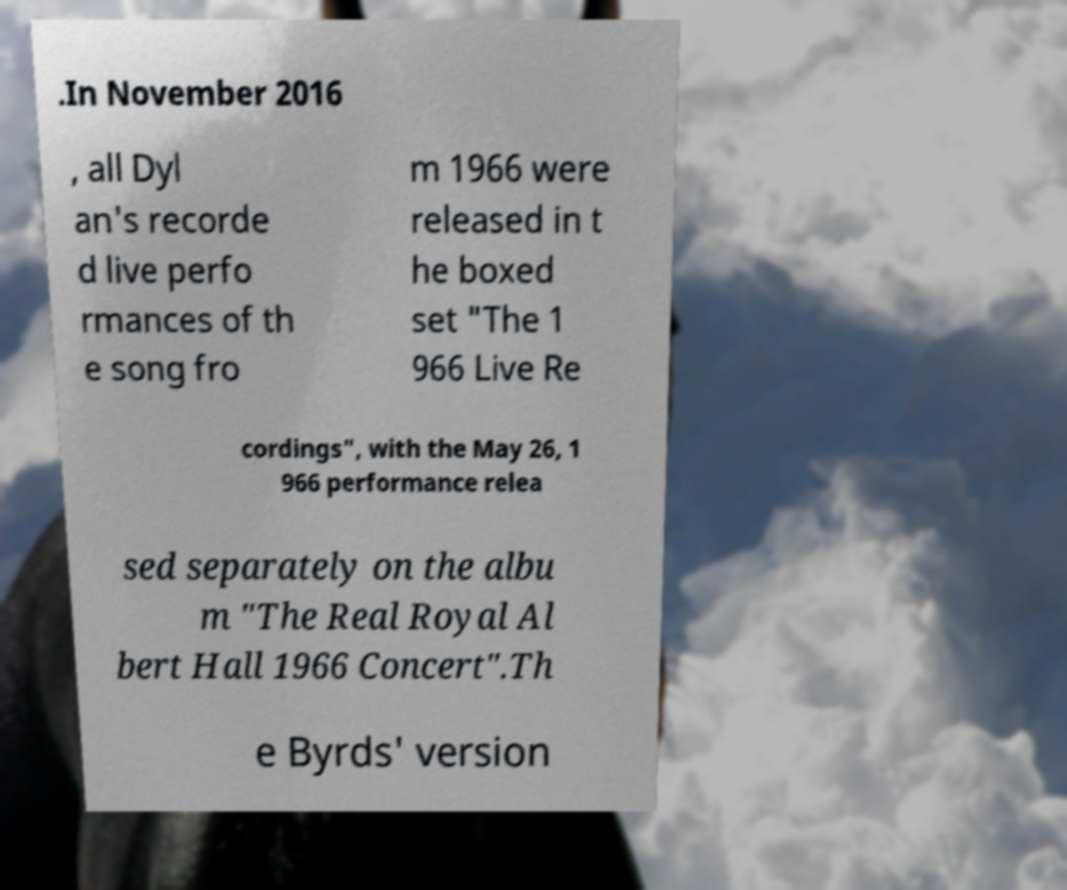Can you accurately transcribe the text from the provided image for me? .In November 2016 , all Dyl an's recorde d live perfo rmances of th e song fro m 1966 were released in t he boxed set "The 1 966 Live Re cordings", with the May 26, 1 966 performance relea sed separately on the albu m "The Real Royal Al bert Hall 1966 Concert".Th e Byrds' version 